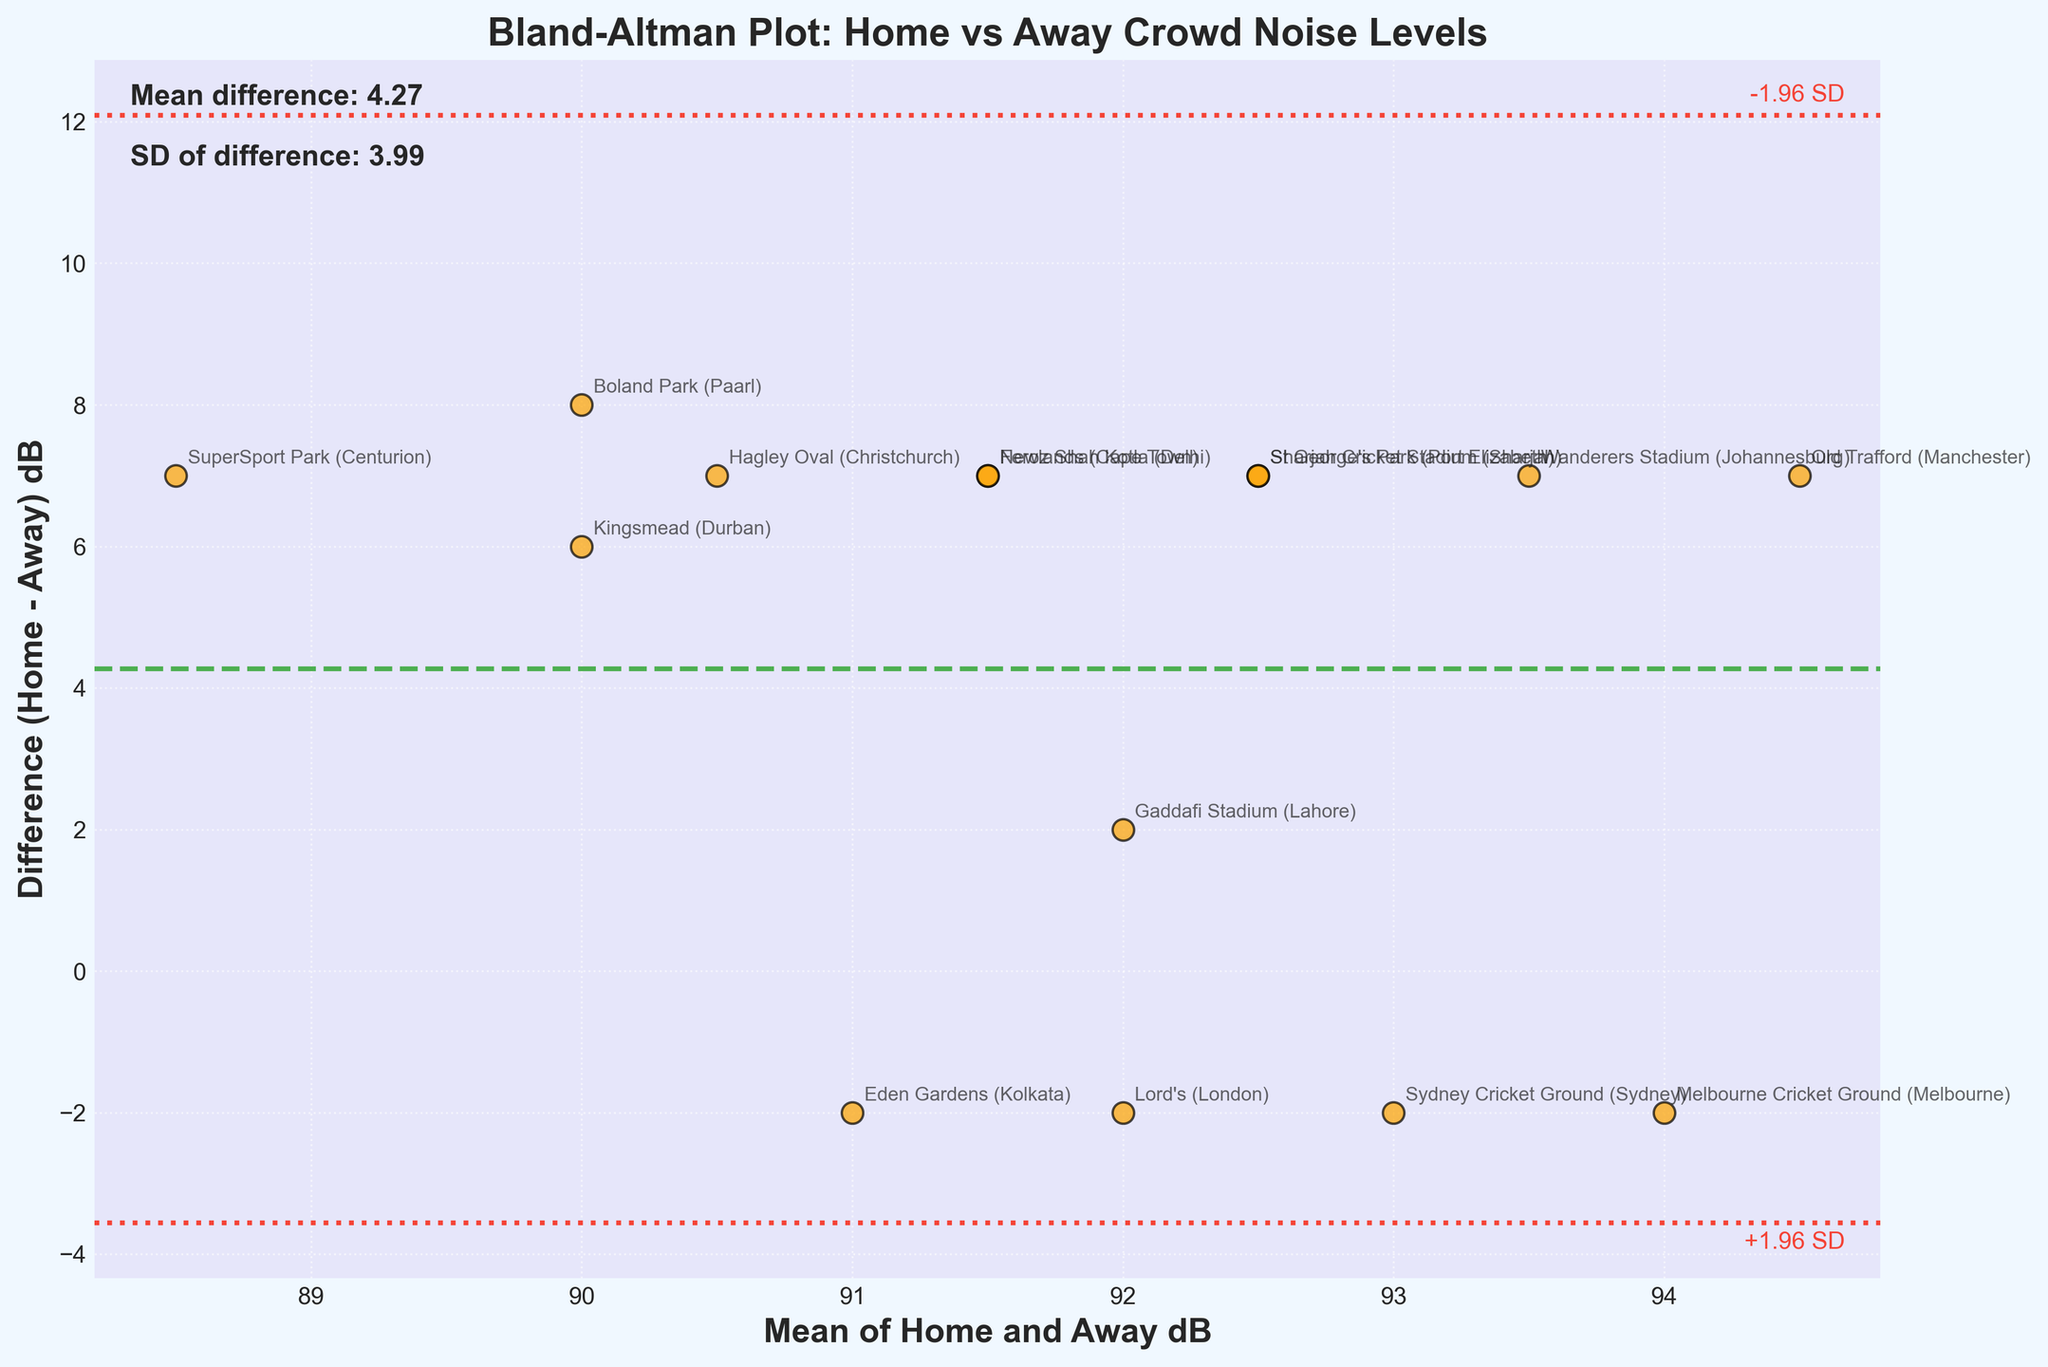What's the title of the plot? The title is typically located at the top of the plot. It provides an overview of what the plot represents. In this case, it mentions something related to crowd noise levels.
Answer: Bland-Altman Plot: Home vs Away Crowd Noise Levels How many data points are compared in this plot? Each data point corresponds to a match location, and there should be a scatter point for each location listed in the data. Counting these points gives the total number of comparisons.
Answer: 15 What does the x-axis represent? The label on the x-axis provides this information. Generally, it indicates the mean values of home and away dB levels for each match.
Answer: Mean of Home and Away dB What does the y-axis represent? The y-axis label indicates what it measures. In this context, it specifies the difference in dB levels between home and away matches.
Answer: Difference (Home - Away) dB What color is used to mark the ±1.96 SD lines? These lines are marked with a specific color to distinguish them visually. By looking at the plot, we can see the color used.
Answer: Red What is the mean difference between home and away crowd noise levels? The exact value of the mean difference is often annotated near the plotted line representing this mean.
Answer: 5.53 dB Which match location had the smallest difference between home and away crowd noise levels? To find this, look for the point closest to the x-axis (zero difference) and check the annotated location.
Answer: Lord's (London) Are the differences in crowd noise levels more often positive or negative? Review the spread of points above and below the x-axis; the majority direction indicates if more differences are positive or negative.
Answer: Positive What is the standard deviation of the differences in crowd noise levels? The standard deviation is typically noted alongside the mean difference.
Answer: 2.09 dB Which match location had the largest positive difference in crowd noise levels? Identify the point highest above the x-axis and read off the annotated location.
Answer: Wanderers Stadium (Johannesburg) 